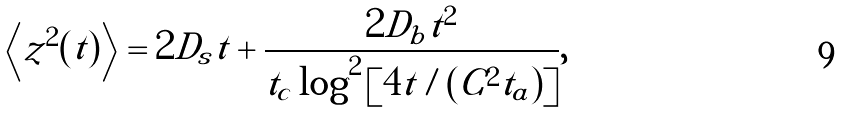Convert formula to latex. <formula><loc_0><loc_0><loc_500><loc_500>\left < z ^ { 2 } ( t ) \right > = 2 D _ { s } t + \frac { 2 D _ { b } t ^ { 2 } } { t _ { c } \log ^ { 2 } \left [ 4 t / ( C ^ { 2 } t _ { a } ) \right ] } ,</formula> 